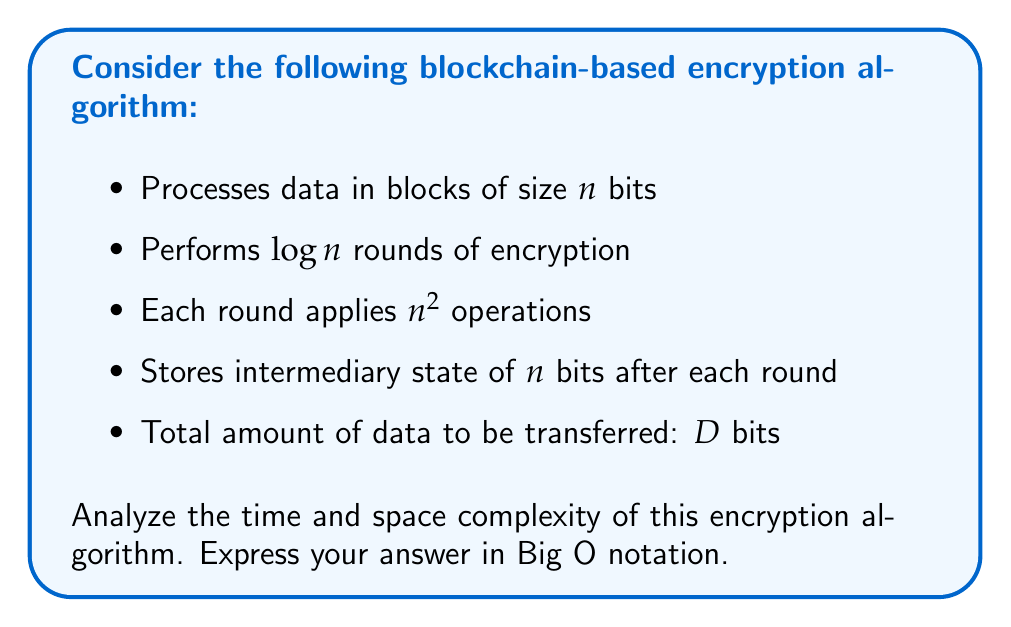Solve this math problem. Let's break down the analysis step-by-step:

1. Time Complexity:
   a. Number of blocks: $\frac{D}{n}$ (total data divided by block size)
   b. For each block:
      - Number of rounds: $\log n$
      - Operations per round: $n^2$
   c. Total operations: $\frac{D}{n} \cdot \log n \cdot n^2 = D \cdot n \cdot \log n$

   Therefore, the time complexity is $O(D \cdot n \cdot \log n)$.

2. Space Complexity:
   a. Input data: $O(n)$ (we process one block at a time)
   b. Intermediary state: $O(n \cdot \log n)$ (we store $n$ bits for each of the $\log n$ rounds)
   c. Output data: $O(n)$ (we produce one encrypted block at a time)

   The total space complexity is the sum of these components: $O(n + n \cdot \log n + n) = O(n \cdot \log n)$.

Note that the space complexity is independent of $D$ because we process the data in blocks of size $n$.
Answer: Time: $O(D \cdot n \cdot \log n)$, Space: $O(n \cdot \log n)$ 